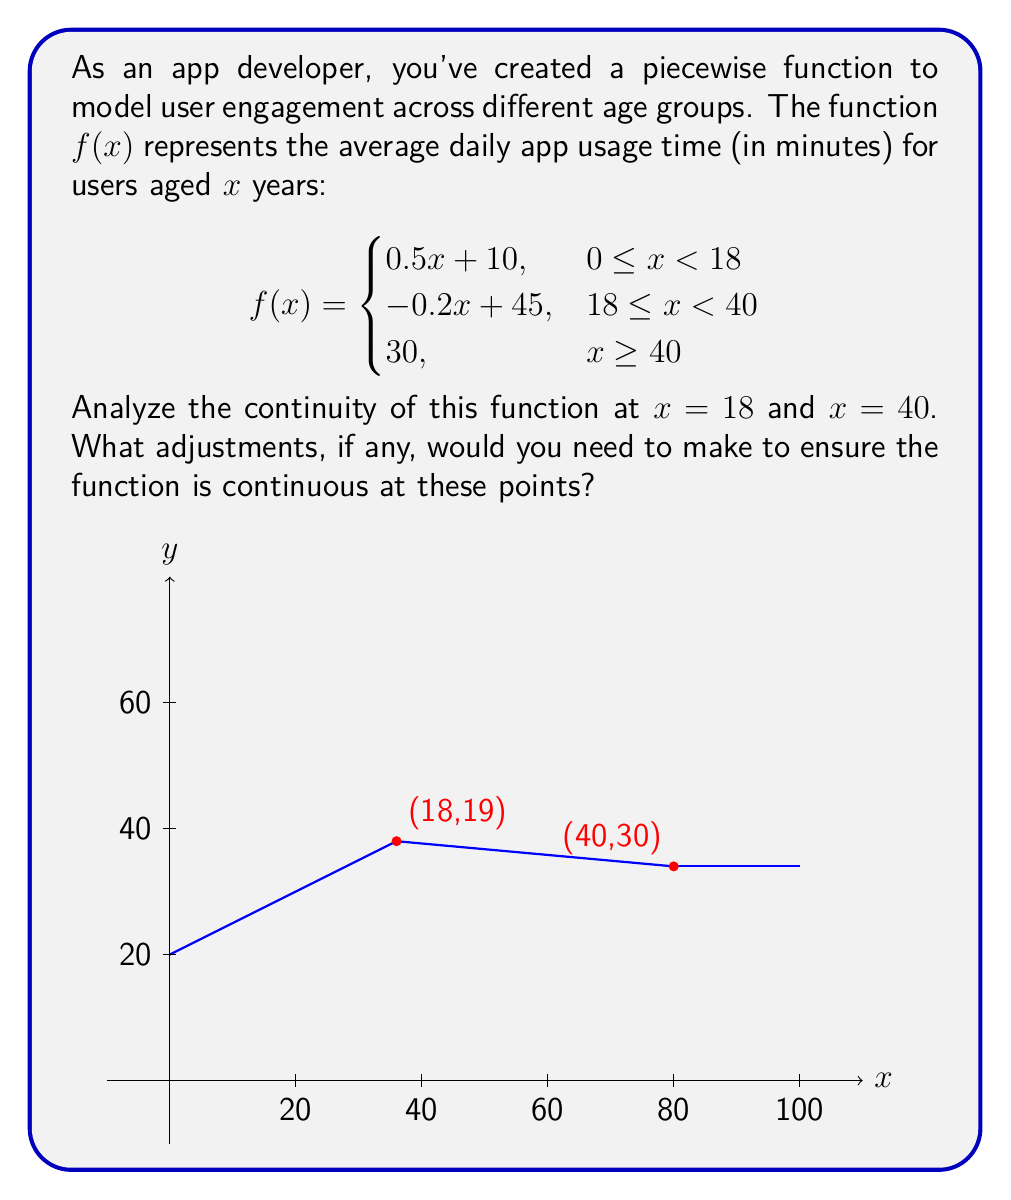Teach me how to tackle this problem. To analyze the continuity of the piecewise function, we need to check if the function is continuous at the transition points $x = 18$ and $x = 40$. A function is continuous at a point if the limit from both sides exists and is equal to the function value at that point.

1. Continuity at $x = 18$:
   
   Left limit: $\lim_{x \to 18^-} f(x) = 0.5(18) + 10 = 19$
   Right limit: $\lim_{x \to 18^+} f(x) = -0.2(18) + 45 = 41.4$
   Function value: $f(18) = -0.2(18) + 45 = 41.4$

   The left limit (19) doesn't match the right limit and function value (41.4), so the function is not continuous at $x = 18$.

2. Continuity at $x = 40$:
   
   Left limit: $\lim_{x \to 40^-} f(x) = -0.2(40) + 45 = 37$
   Right limit: $\lim_{x \to 40^+} f(x) = 30$
   Function value: $f(40) = 30$

   The left limit (37) doesn't match the right limit and function value (30), so the function is not continuous at $x = 40$.

To make the function continuous:

1. At $x = 18$, adjust the first piece:
   $0.5x + 10$ should become $0.5x + 32.4$ to make $f(18) = 41.4$

2. At $x = 40$, adjust the second piece:
   $-0.2x + 45$ should become $-0.175x + 37$ to make $f(40) = 30$

The continuous piecewise function would be:

$$f(x) = \begin{cases}
0.5x + 32.4, & 0 \leq x < 18 \\
-0.175x + 37, & 18 \leq x < 40 \\
30, & x \geq 40
\end{cases}$$
Answer: Adjust first piece to $0.5x + 32.4$ and second piece to $-0.175x + 37$. 